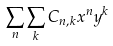<formula> <loc_0><loc_0><loc_500><loc_500>\sum _ { n } \sum _ { k } C _ { n , k } x ^ { n } y ^ { k }</formula> 